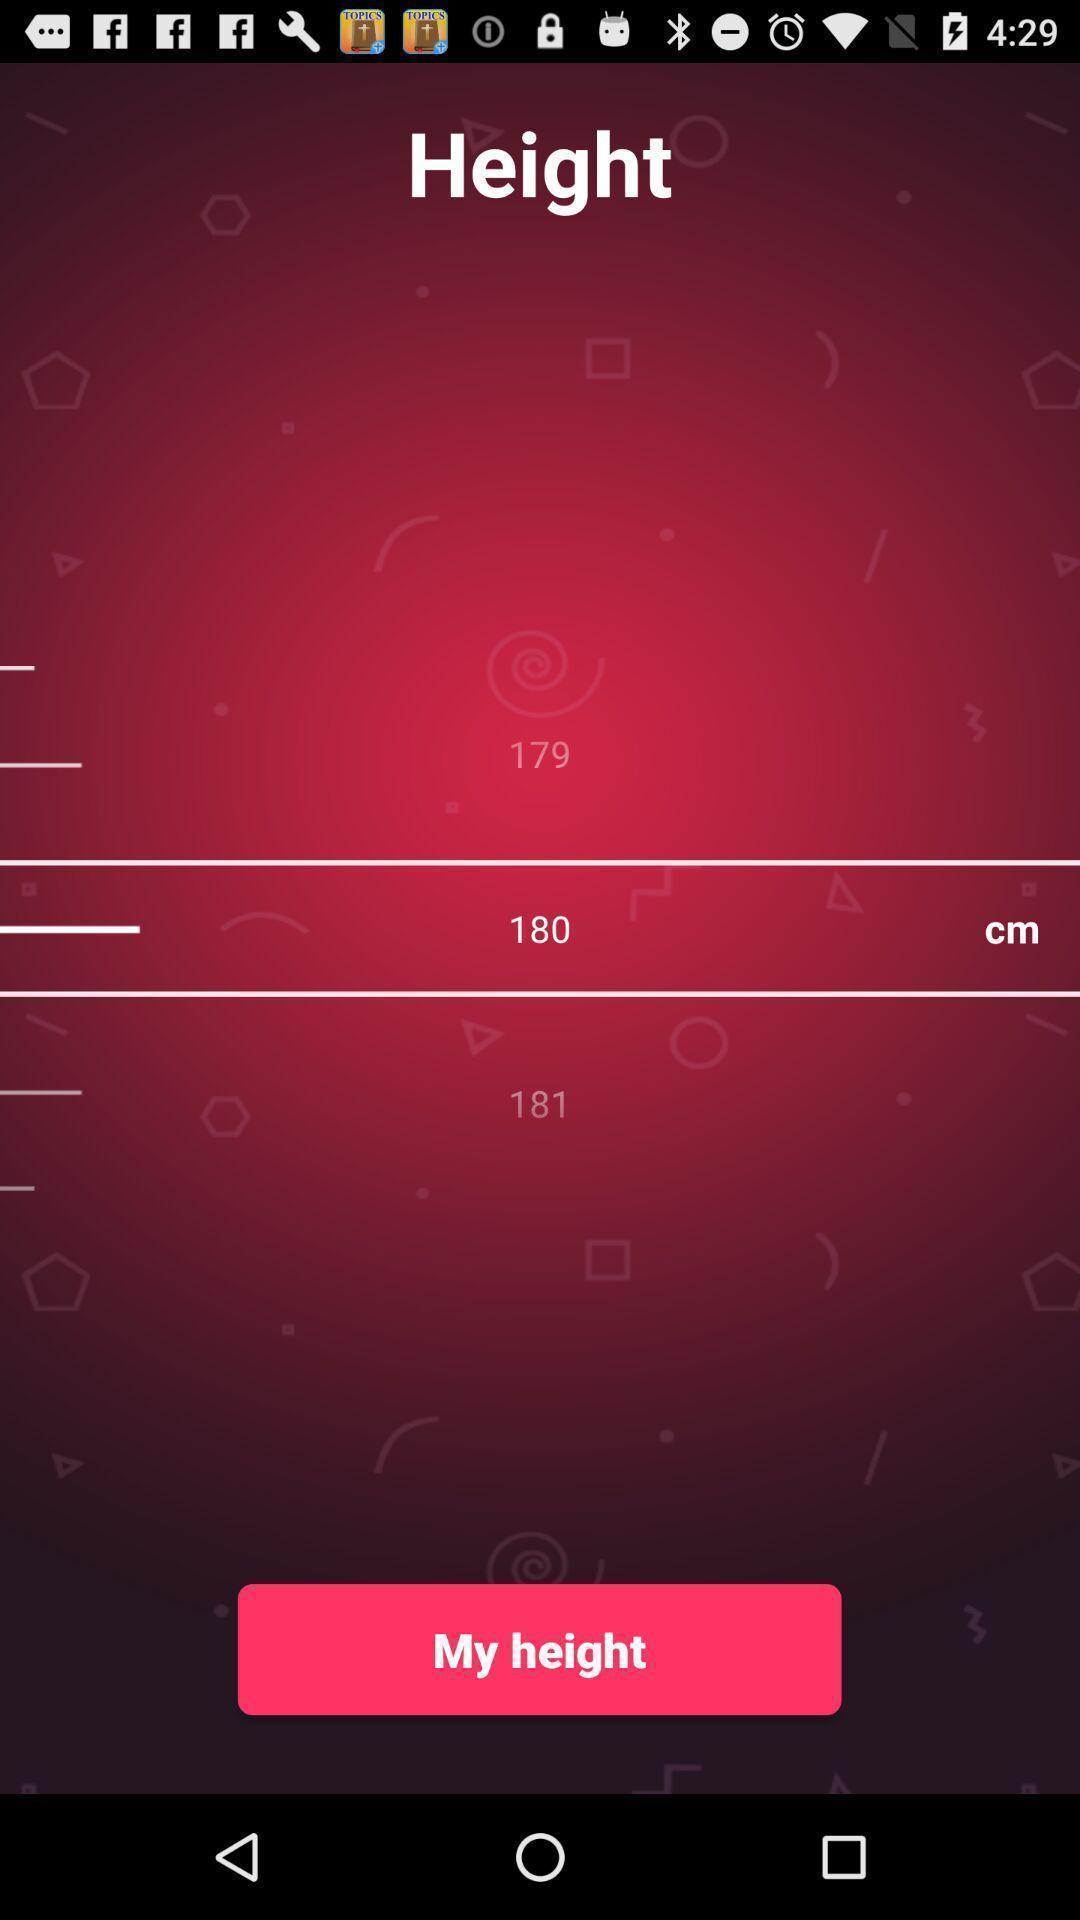Summarize the main components in this picture. Screen displaying multiple measurement options. 